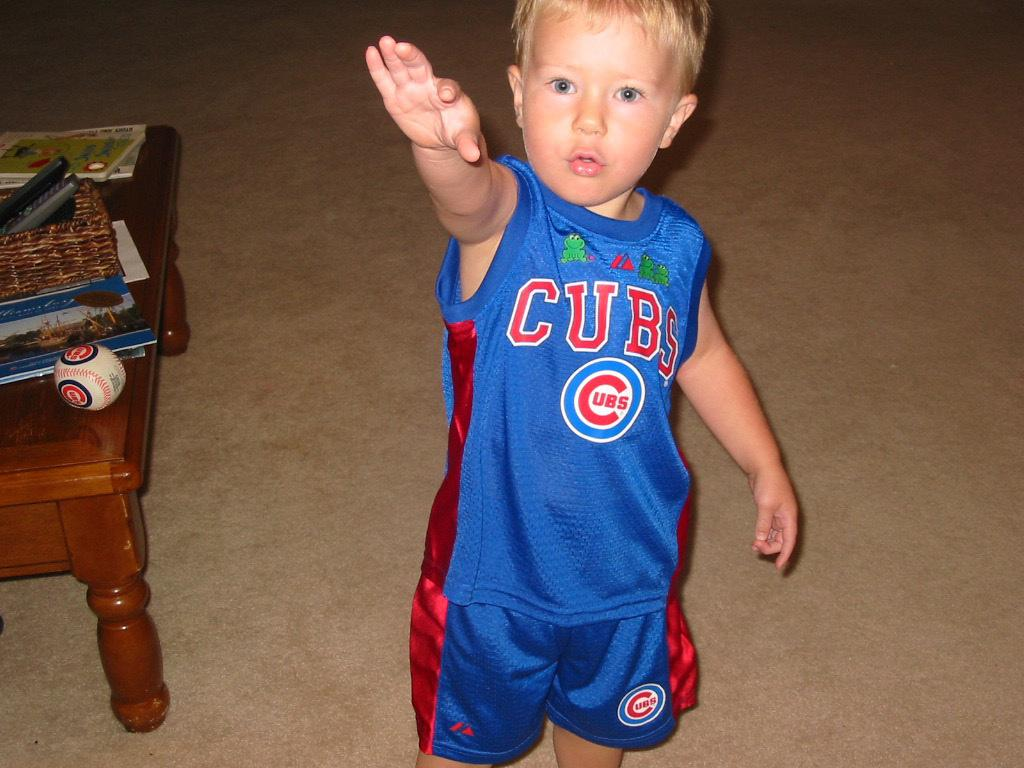Who is in the picture? There is a boy in the picture. What is the boy wearing? The boy is wearing a red and blue shirt and shorts. What can be seen on the table in the image? There is a book and a ball on the table. What is the boy doing with his right hand? The boy is raising his right hand. How many trains are visible in the image? There are no trains present in the image. What type of paper is the boy holding in the image? The boy is not holding any paper in the image. 